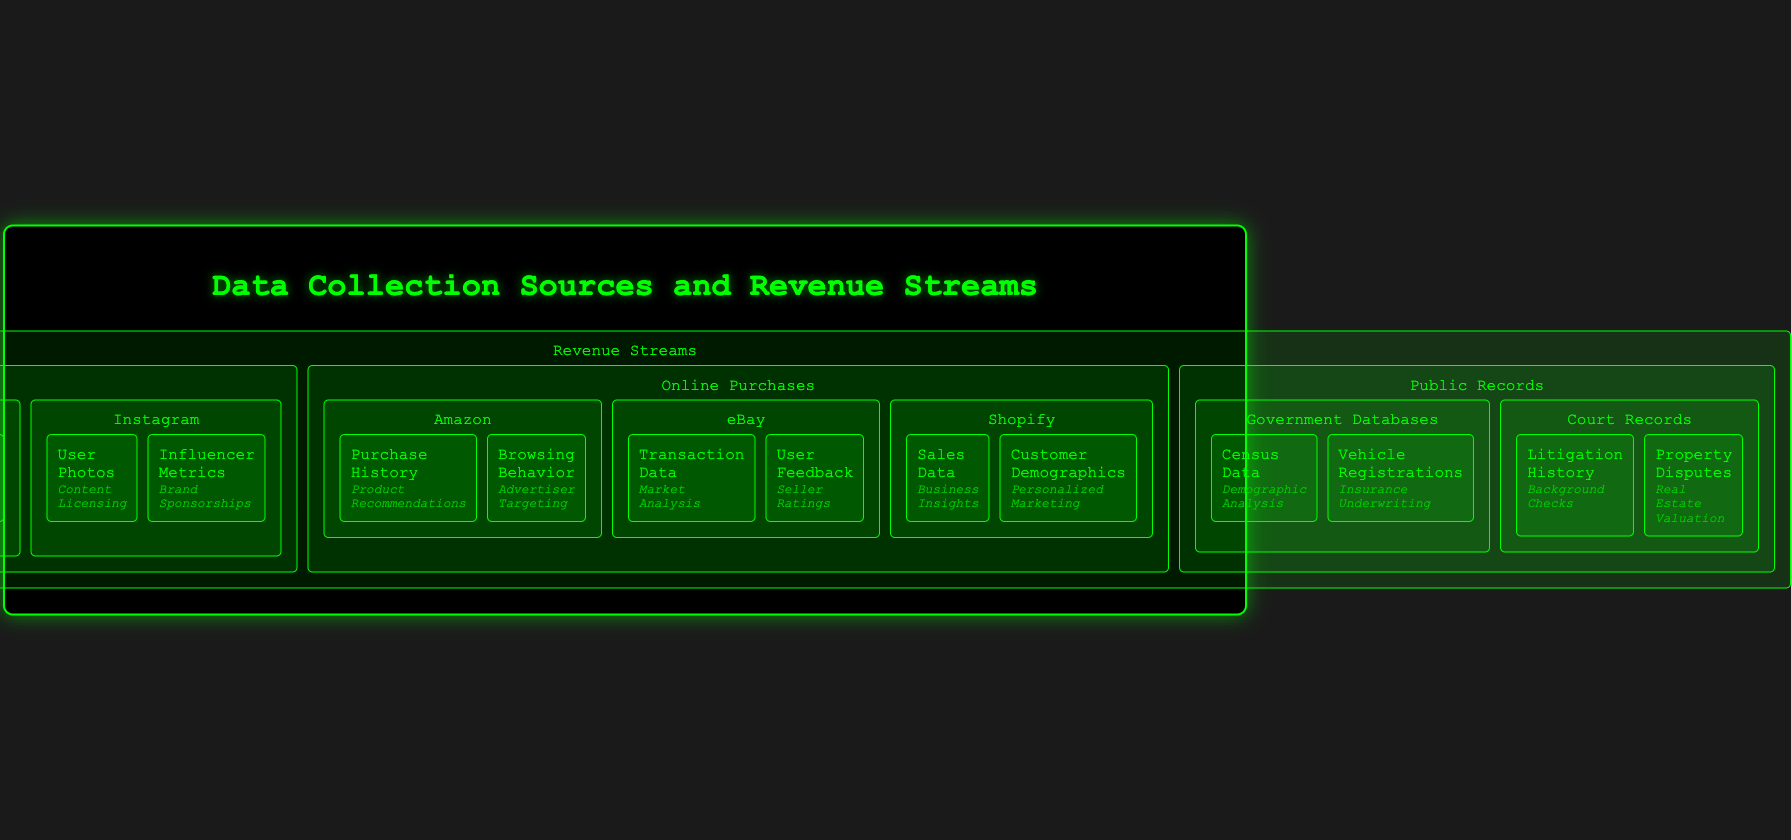What are the three main revenue sources? The three main revenue sources outlined in the infographic are Social Media Platforms, Online Purchases, and Public Records.
Answer: Social Media Platforms, Online Purchases, Public Records Which platform has targeted advertising as a revenue stream? Targeted advertising is listed as a revenue stream under Facebook, which is part of the Social Media Platforms category.
Answer: Facebook What type of data does eBay provide for market analysis? eBay's transaction data is specifically noted as a source for market analysis in the Online Purchases section.
Answer: Transaction Data What is generated from government census data? The infographic states that demographic analysis is generated from government census data under Public Records.
Answer: Demographic Analysis Which platform offers personalized marketing based on customer demographics? Shopify provides personalized marketing from customer demographics information in the Online Purchases area.
Answer: Shopify How does Twitter generate revenue from follower information? Twitter generates revenue through audience insights derived from follower information under Social Media Platforms.
Answer: Audience Insights What data type does litigation history provide for background checks? Litigation history under Court Records is used for background checks as shown in the infographic.
Answer: Background Checks What revenue stream is associated with influencer metrics on Instagram? Influencer metrics on Instagram contribute to brand sponsorships according to the data provided.
Answer: Brand Sponsorships 